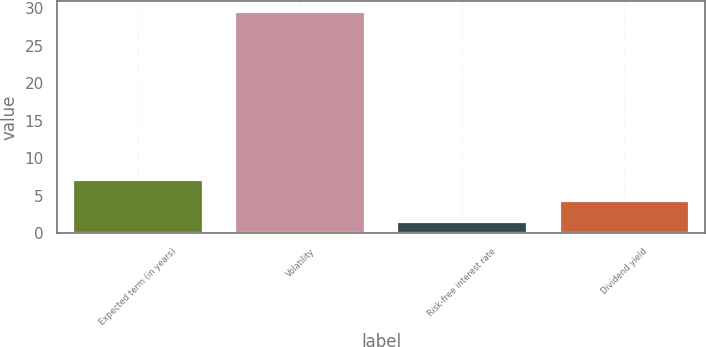<chart> <loc_0><loc_0><loc_500><loc_500><bar_chart><fcel>Expected term (in years)<fcel>Volatility<fcel>Risk-free interest rate<fcel>Dividend yield<nl><fcel>7.14<fcel>29.5<fcel>1.54<fcel>4.34<nl></chart> 